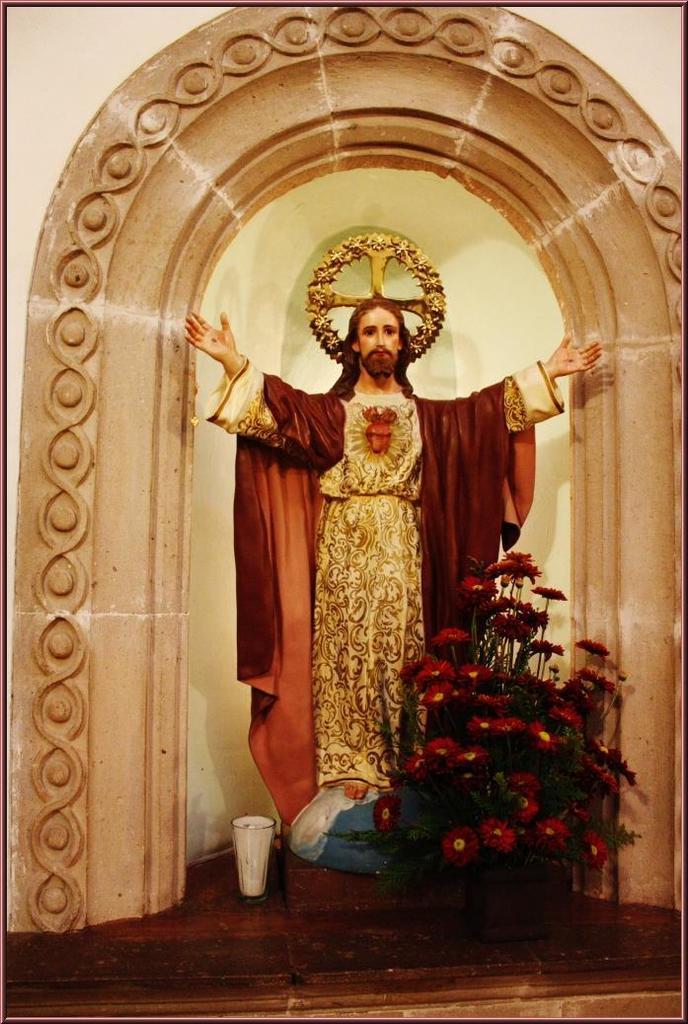Could you give a brief overview of what you see in this image? In this image there is a statue of a Jesus Christ, in front of the statue there is a bouquet and a depiction of glass. In the background there is a wall. 